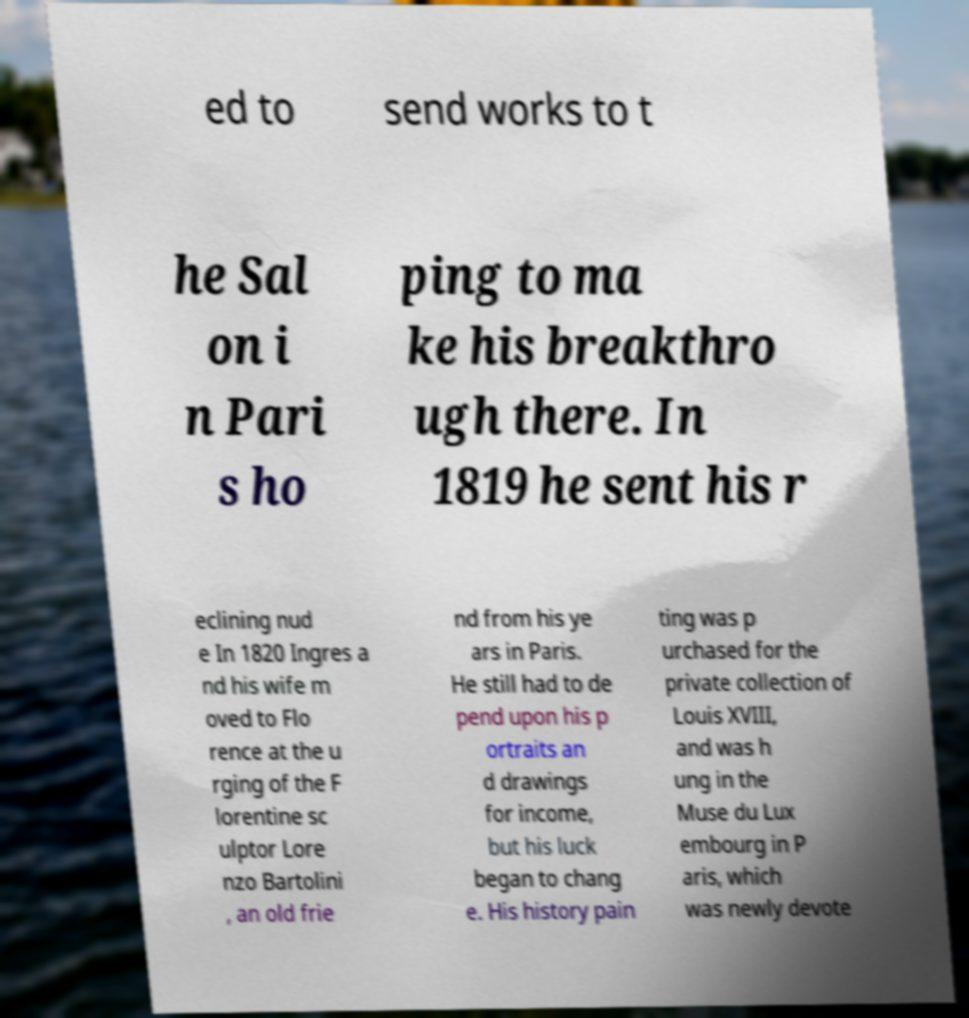Please identify and transcribe the text found in this image. ed to send works to t he Sal on i n Pari s ho ping to ma ke his breakthro ugh there. In 1819 he sent his r eclining nud e In 1820 Ingres a nd his wife m oved to Flo rence at the u rging of the F lorentine sc ulptor Lore nzo Bartolini , an old frie nd from his ye ars in Paris. He still had to de pend upon his p ortraits an d drawings for income, but his luck began to chang e. His history pain ting was p urchased for the private collection of Louis XVIII, and was h ung in the Muse du Lux embourg in P aris, which was newly devote 